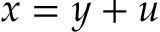Convert formula to latex. <formula><loc_0><loc_0><loc_500><loc_500>x = y + u</formula> 